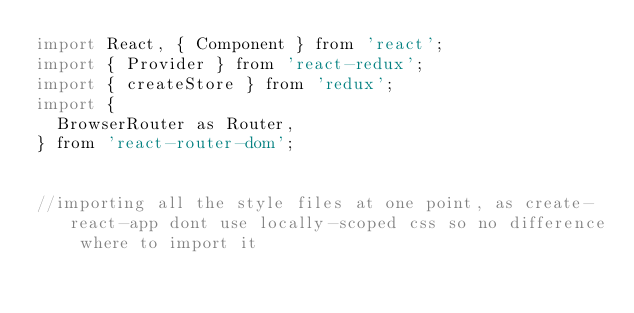Convert code to text. <code><loc_0><loc_0><loc_500><loc_500><_JavaScript_>import React, { Component } from 'react';
import { Provider } from 'react-redux';
import { createStore } from 'redux';
import {
  BrowserRouter as Router,
} from 'react-router-dom';

    
//importing all the style files at one point, as create-react-app dont use locally-scoped css so no difference where to import it
    </code> 